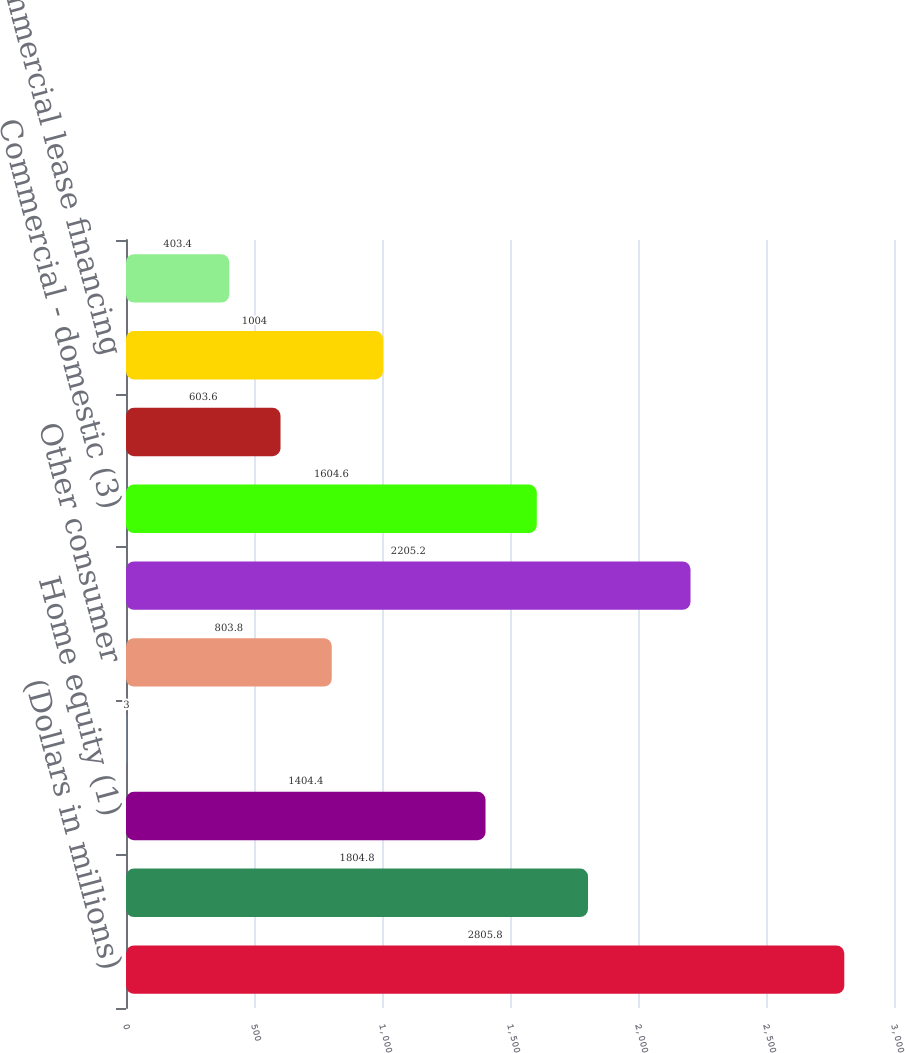Convert chart. <chart><loc_0><loc_0><loc_500><loc_500><bar_chart><fcel>(Dollars in millions)<fcel>Residential mortgage<fcel>Home equity (1)<fcel>Direct/Indirect consumer (1)<fcel>Other consumer<fcel>Total consumer (2)<fcel>Commercial - domestic (3)<fcel>Commercial real estate<fcel>Commercial lease financing<fcel>Commercial - foreign<nl><fcel>2805.8<fcel>1804.8<fcel>1404.4<fcel>3<fcel>803.8<fcel>2205.2<fcel>1604.6<fcel>603.6<fcel>1004<fcel>403.4<nl></chart> 